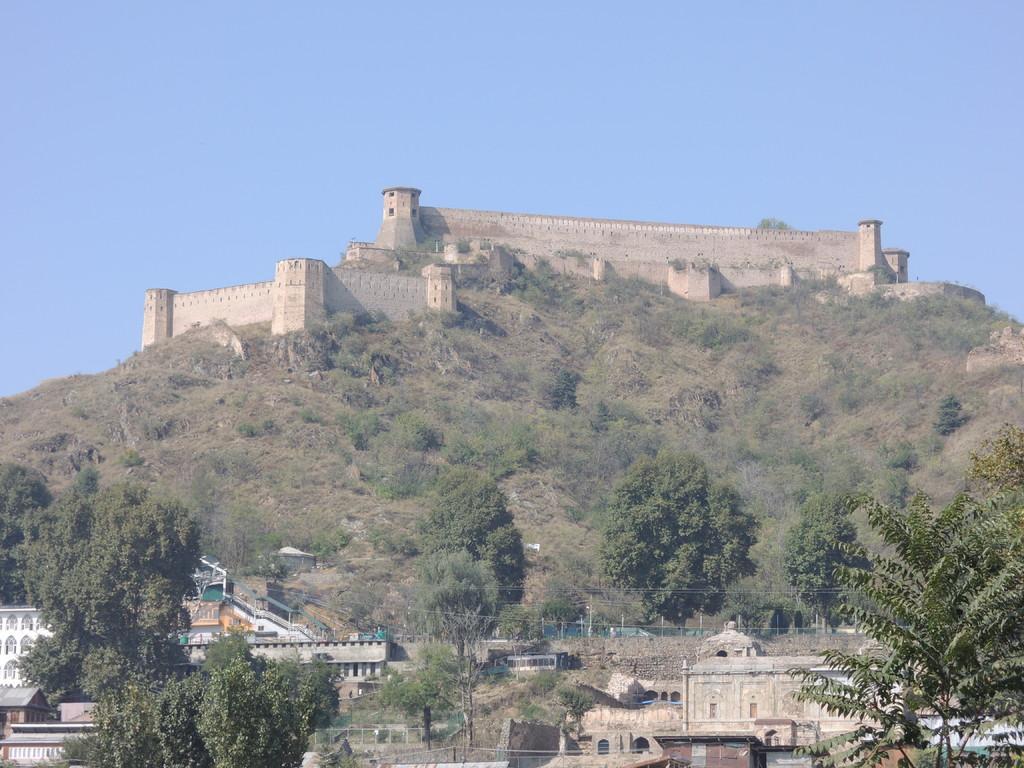Describe this image in one or two sentences. In this image there are some trees and some houses in the bottom of this image,and there is a mountain in the background. There is a fort is on to this mountain. There is a sky on the top of this image. 